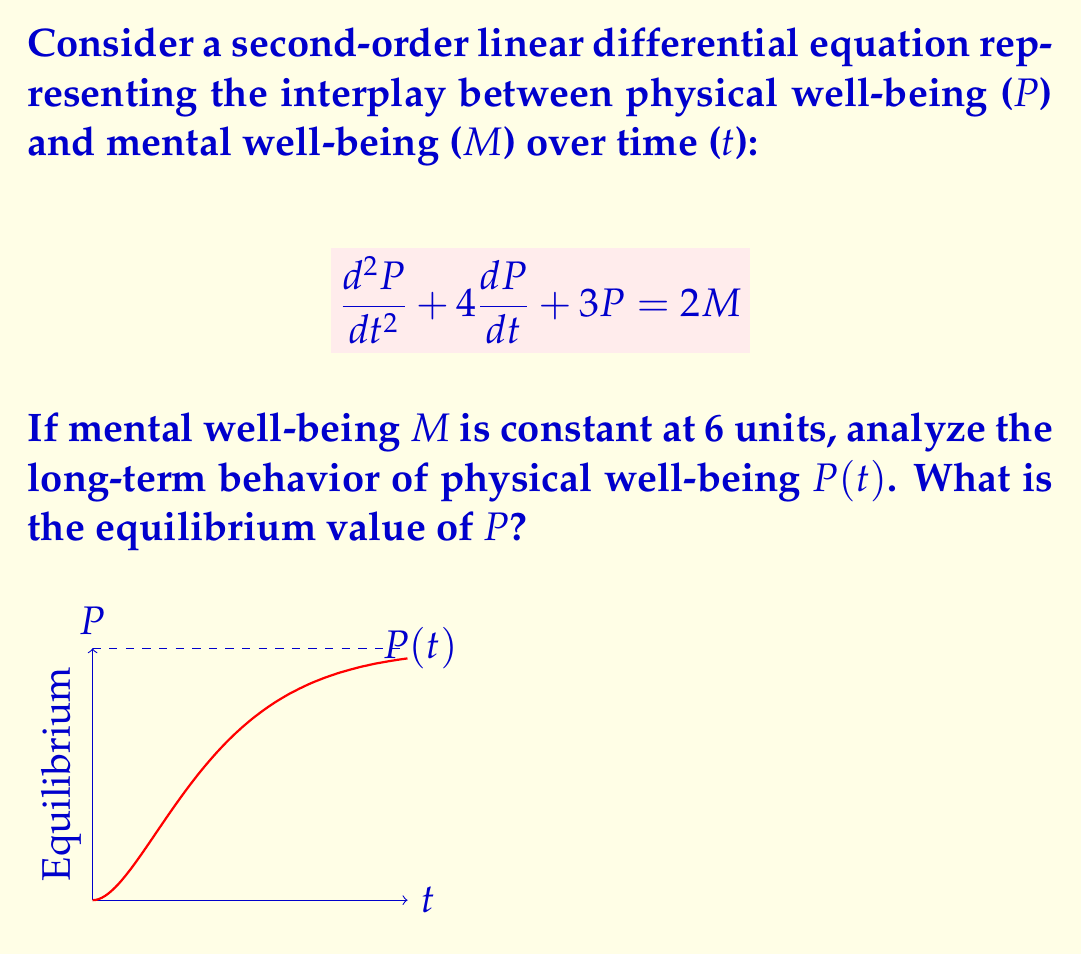Help me with this question. To analyze the long-term behavior and find the equilibrium value of $P$, we follow these steps:

1) First, we recognize that at equilibrium, all derivatives will be zero. So, we set $\frac{d^2P}{dt^2} = \frac{dP}{dt} = 0$ in the original equation:

   $$0 + 0 + 3P = 2M$$

2) We're given that $M = 6$, so we substitute this:

   $$3P = 2(6)$$
   $$3P = 12$$

3) Solving for $P$:

   $$P = \frac{12}{3} = 4$$

4) To confirm this is indeed the long-term behavior, we can analyze the homogeneous part of the equation:

   $$\frac{d^2P}{dt^2} + 4\frac{dP}{dt} + 3P = 0$$

   The characteristic equation is $r^2 + 4r + 3 = 0$, which has roots $r_1 = -1$ and $r_2 = -3$.

5) Since both roots are negative real numbers, any transient solutions will decay exponentially, leaving only the particular solution (our equilibrium value) in the long term.

Therefore, the physical well-being $P(t)$ will approach and stabilize at the equilibrium value of 4 units as $t \to \infty$, regardless of initial conditions.
Answer: $P = 4$ 